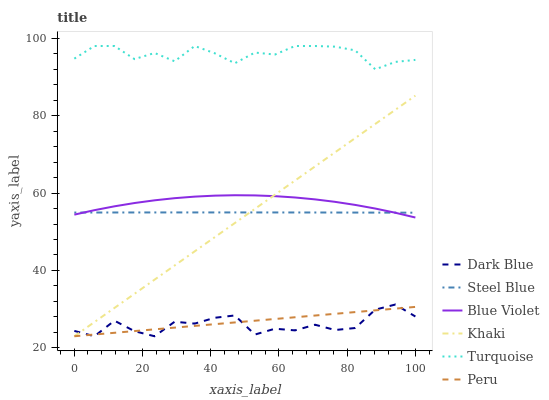Does Dark Blue have the minimum area under the curve?
Answer yes or no. Yes. Does Turquoise have the maximum area under the curve?
Answer yes or no. Yes. Does Khaki have the minimum area under the curve?
Answer yes or no. No. Does Khaki have the maximum area under the curve?
Answer yes or no. No. Is Peru the smoothest?
Answer yes or no. Yes. Is Dark Blue the roughest?
Answer yes or no. Yes. Is Khaki the smoothest?
Answer yes or no. No. Is Khaki the roughest?
Answer yes or no. No. Does Khaki have the lowest value?
Answer yes or no. Yes. Does Steel Blue have the lowest value?
Answer yes or no. No. Does Turquoise have the highest value?
Answer yes or no. Yes. Does Khaki have the highest value?
Answer yes or no. No. Is Blue Violet less than Turquoise?
Answer yes or no. Yes. Is Blue Violet greater than Dark Blue?
Answer yes or no. Yes. Does Khaki intersect Blue Violet?
Answer yes or no. Yes. Is Khaki less than Blue Violet?
Answer yes or no. No. Is Khaki greater than Blue Violet?
Answer yes or no. No. Does Blue Violet intersect Turquoise?
Answer yes or no. No. 